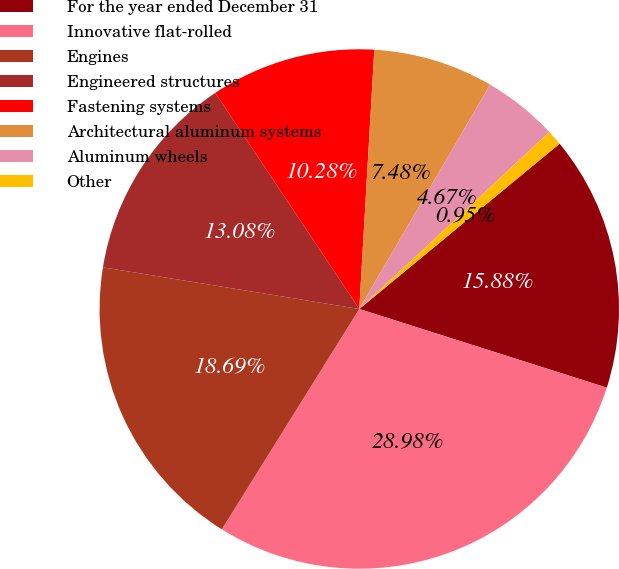<chart> <loc_0><loc_0><loc_500><loc_500><pie_chart><fcel>For the year ended December 31<fcel>Innovative flat-rolled<fcel>Engines<fcel>Engineered structures<fcel>Fastening systems<fcel>Architectural aluminum systems<fcel>Aluminum wheels<fcel>Other<nl><fcel>15.88%<fcel>28.98%<fcel>18.69%<fcel>13.08%<fcel>10.28%<fcel>7.48%<fcel>4.67%<fcel>0.95%<nl></chart> 